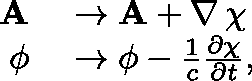<formula> <loc_0><loc_0><loc_500><loc_500>\begin{array} { r l } { A } & \to A + \nabla \, \chi } \\ { \phi } & \to \phi - \frac { 1 } { c } \frac { \partial \chi } { \partial t } , } \end{array}</formula> 